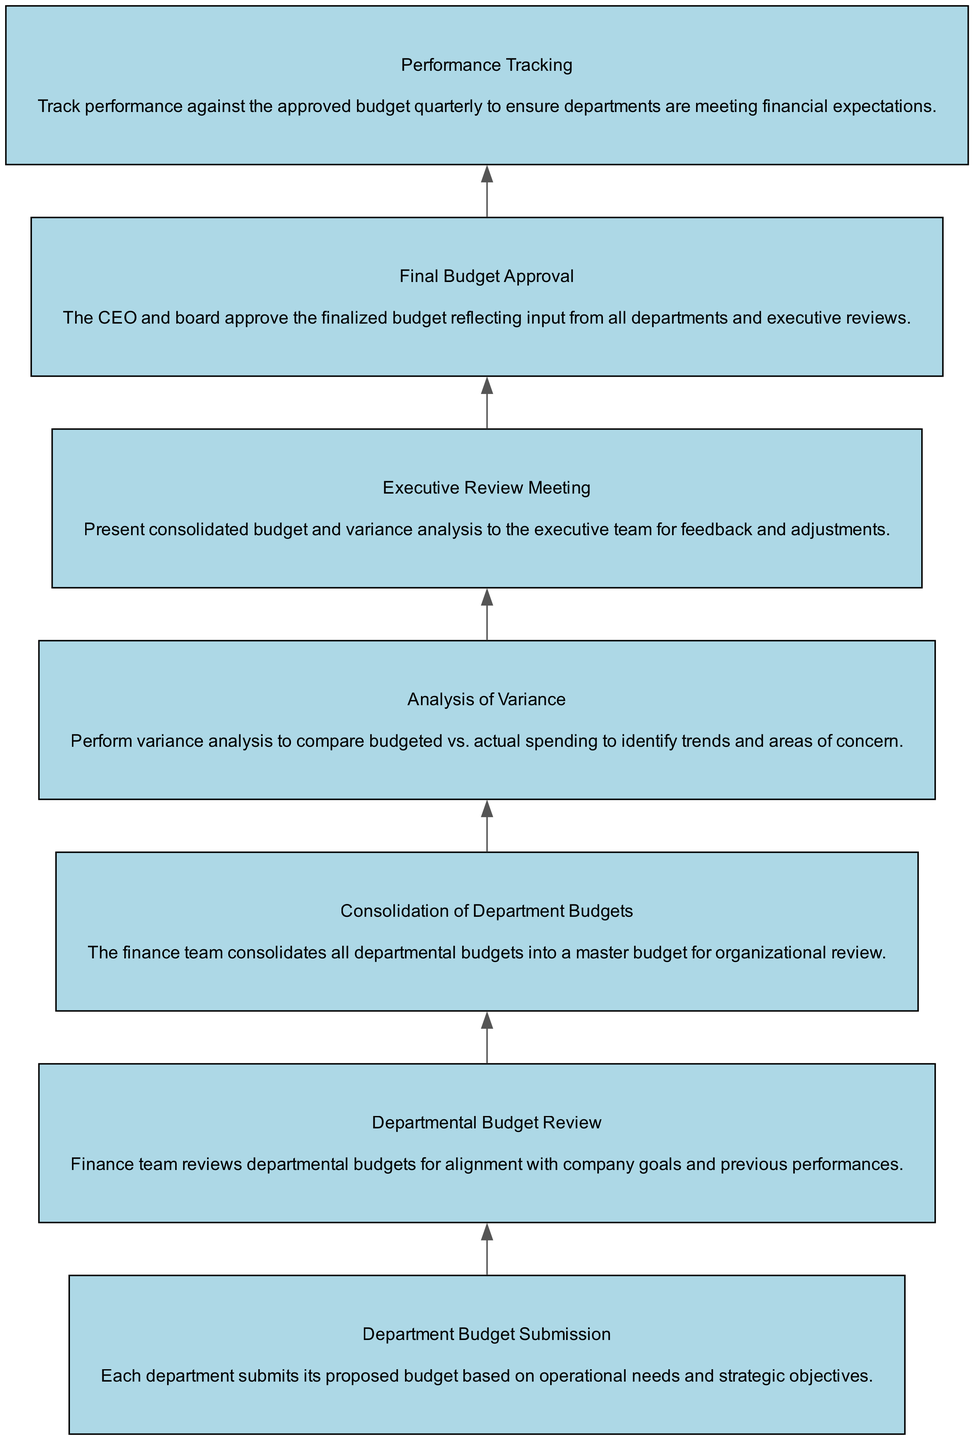What is the first step in the process? The first step in the process is "Department Budget Submission," where each department submits its proposed budget based on operational needs and strategic objectives.
Answer: Department Budget Submission How many nodes are there in the diagram? There are 7 nodes in the diagram, each representing a step in the Quarterly Financial Review Process.
Answer: 7 What is the last step in the process? The last step in the process is "Performance Tracking," which involves tracking performance against the approved budget quarterly to ensure departments are meeting financial expectations.
Answer: Performance Tracking Which node follows "Analysis of Variance"? The node that follows "Analysis of Variance" is "Executive Review Meeting," where the consolidated budget and variance analysis are presented to the executive team for feedback and adjustments.
Answer: Executive Review Meeting What are the two nodes directly connected to "Final Budget Approval"? The two nodes directly connected to "Final Budget Approval" are "Executive Review Meeting" (preceding it) and "Performance Tracking" (following it).
Answer: Executive Review Meeting, Performance Tracking Which step involves the finance team? The steps that involve the finance team are "Departmental Budget Review," "Consolidation of Department Budgets," and "Analysis of Variance."
Answer: Departmental Budget Review, Consolidation of Department Budgets, Analysis of Variance After what step is the budget approved? The budget is approved after the "Executive Review Meeting," where feedback is given before moving to "Final Budget Approval."
Answer: Executive Review Meeting What kind of analysis is performed before presenting to the executive team? Variance analysis is performed to compare budgeted versus actual spending to identify trends and areas of concern before presenting to the executive team.
Answer: Variance analysis How does the process begin? The process begins with the submission of departmental budgets based on operational needs and strategic objectives.
Answer: Department Budget Submission 